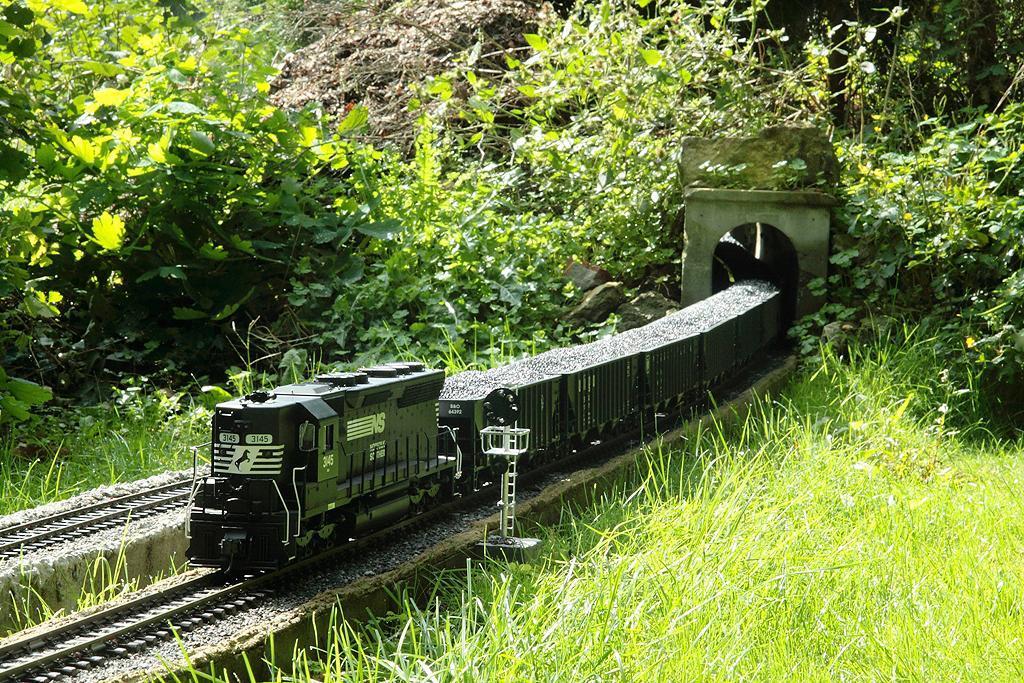How would you summarize this image in a sentence or two? In this image we can see a train on the track. We can also see some grass, plants and a pole. 